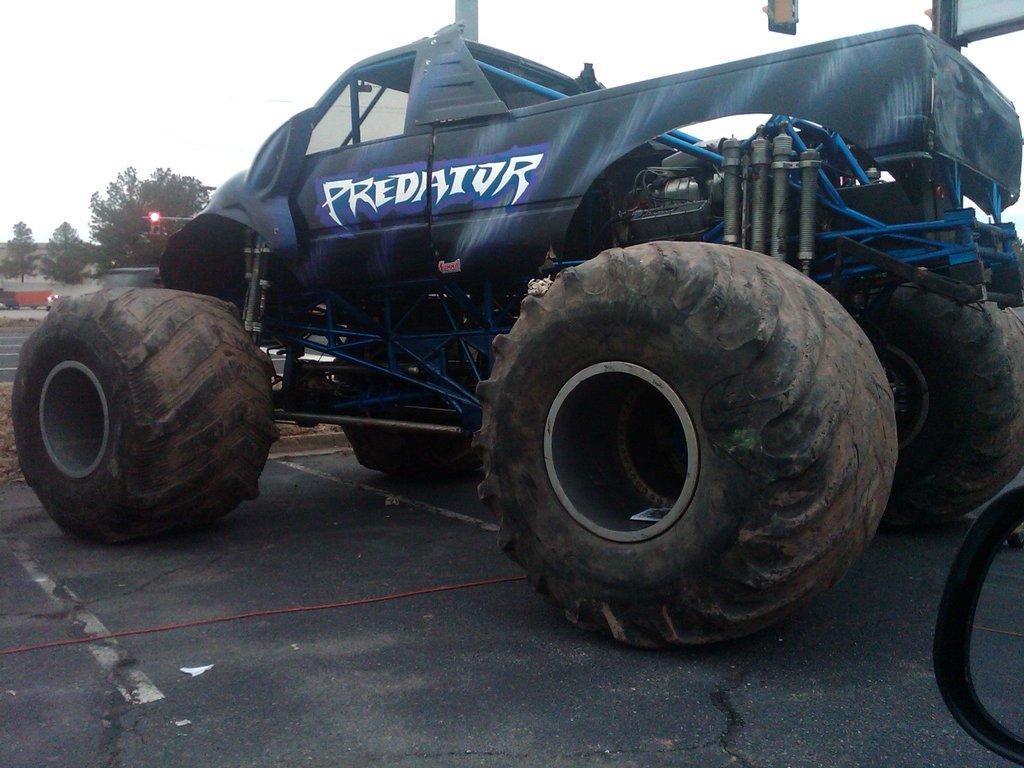Please provide a concise description of this image. In this picture, there is a truck with huge tires with some text. At the bottom, there is a road. In the background, there are trees and a sky. 